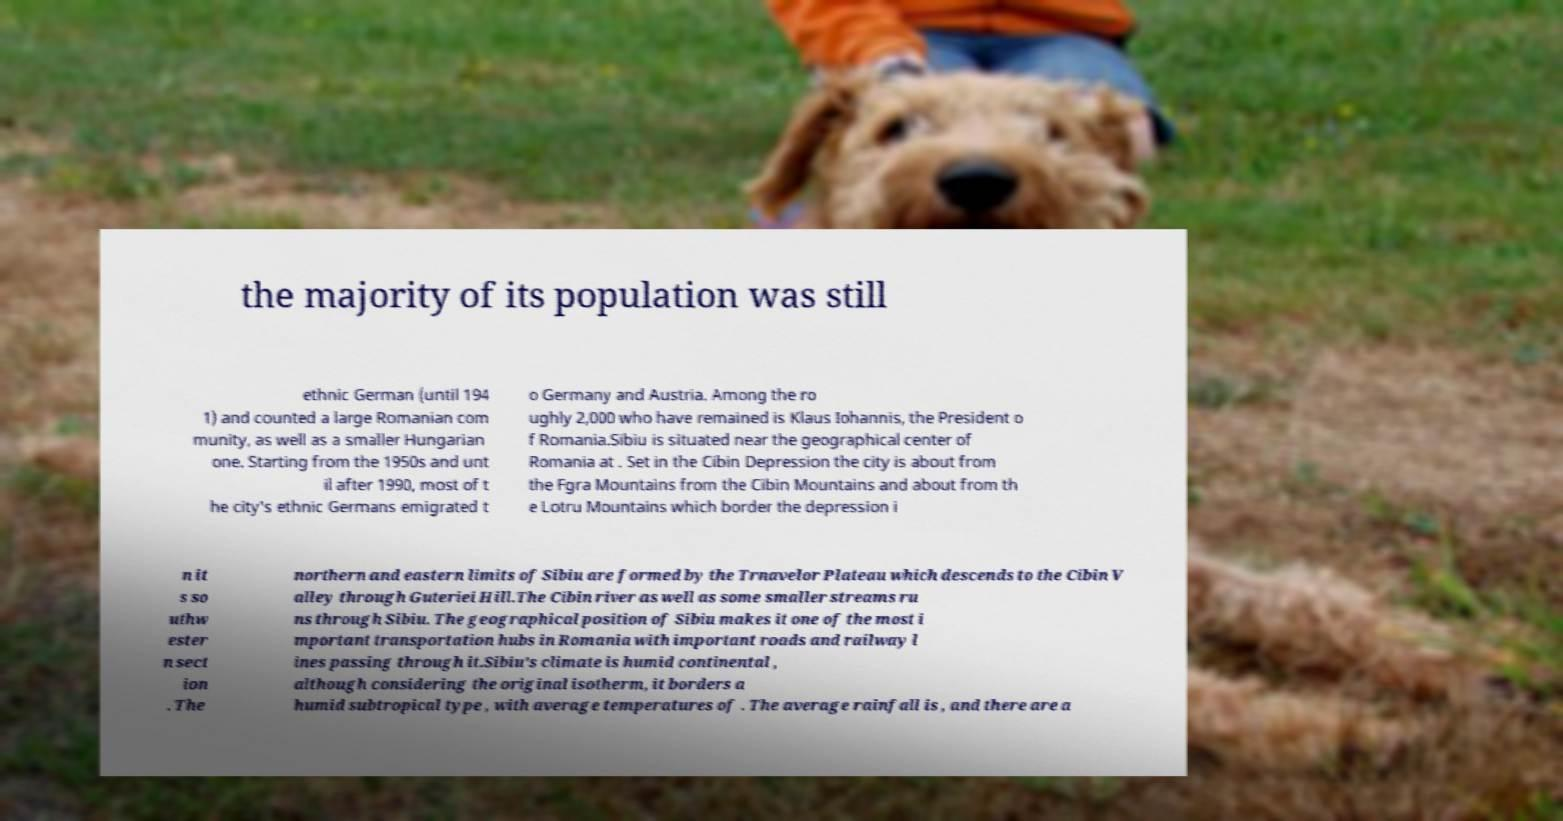I need the written content from this picture converted into text. Can you do that? the majority of its population was still ethnic German (until 194 1) and counted a large Romanian com munity, as well as a smaller Hungarian one. Starting from the 1950s and unt il after 1990, most of t he city's ethnic Germans emigrated t o Germany and Austria. Among the ro ughly 2,000 who have remained is Klaus Iohannis, the President o f Romania.Sibiu is situated near the geographical center of Romania at . Set in the Cibin Depression the city is about from the Fgra Mountains from the Cibin Mountains and about from th e Lotru Mountains which border the depression i n it s so uthw ester n sect ion . The northern and eastern limits of Sibiu are formed by the Trnavelor Plateau which descends to the Cibin V alley through Guteriei Hill.The Cibin river as well as some smaller streams ru ns through Sibiu. The geographical position of Sibiu makes it one of the most i mportant transportation hubs in Romania with important roads and railway l ines passing through it.Sibiu's climate is humid continental , although considering the original isotherm, it borders a humid subtropical type , with average temperatures of . The average rainfall is , and there are a 